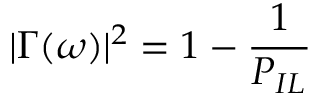<formula> <loc_0><loc_0><loc_500><loc_500>| \Gamma ( \omega ) | ^ { 2 } = 1 - \frac { 1 } { P _ { I L } }</formula> 